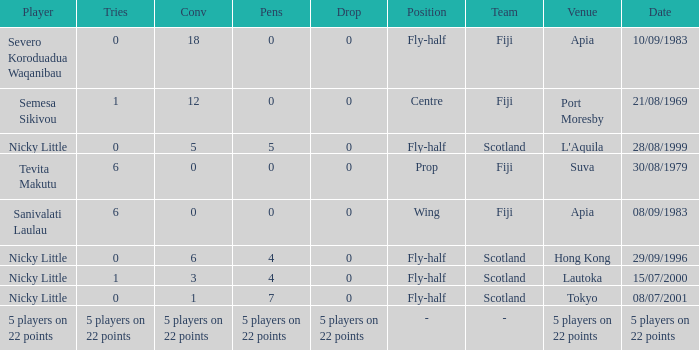How many conversions had 0 pens and 0 tries? 18.0. 